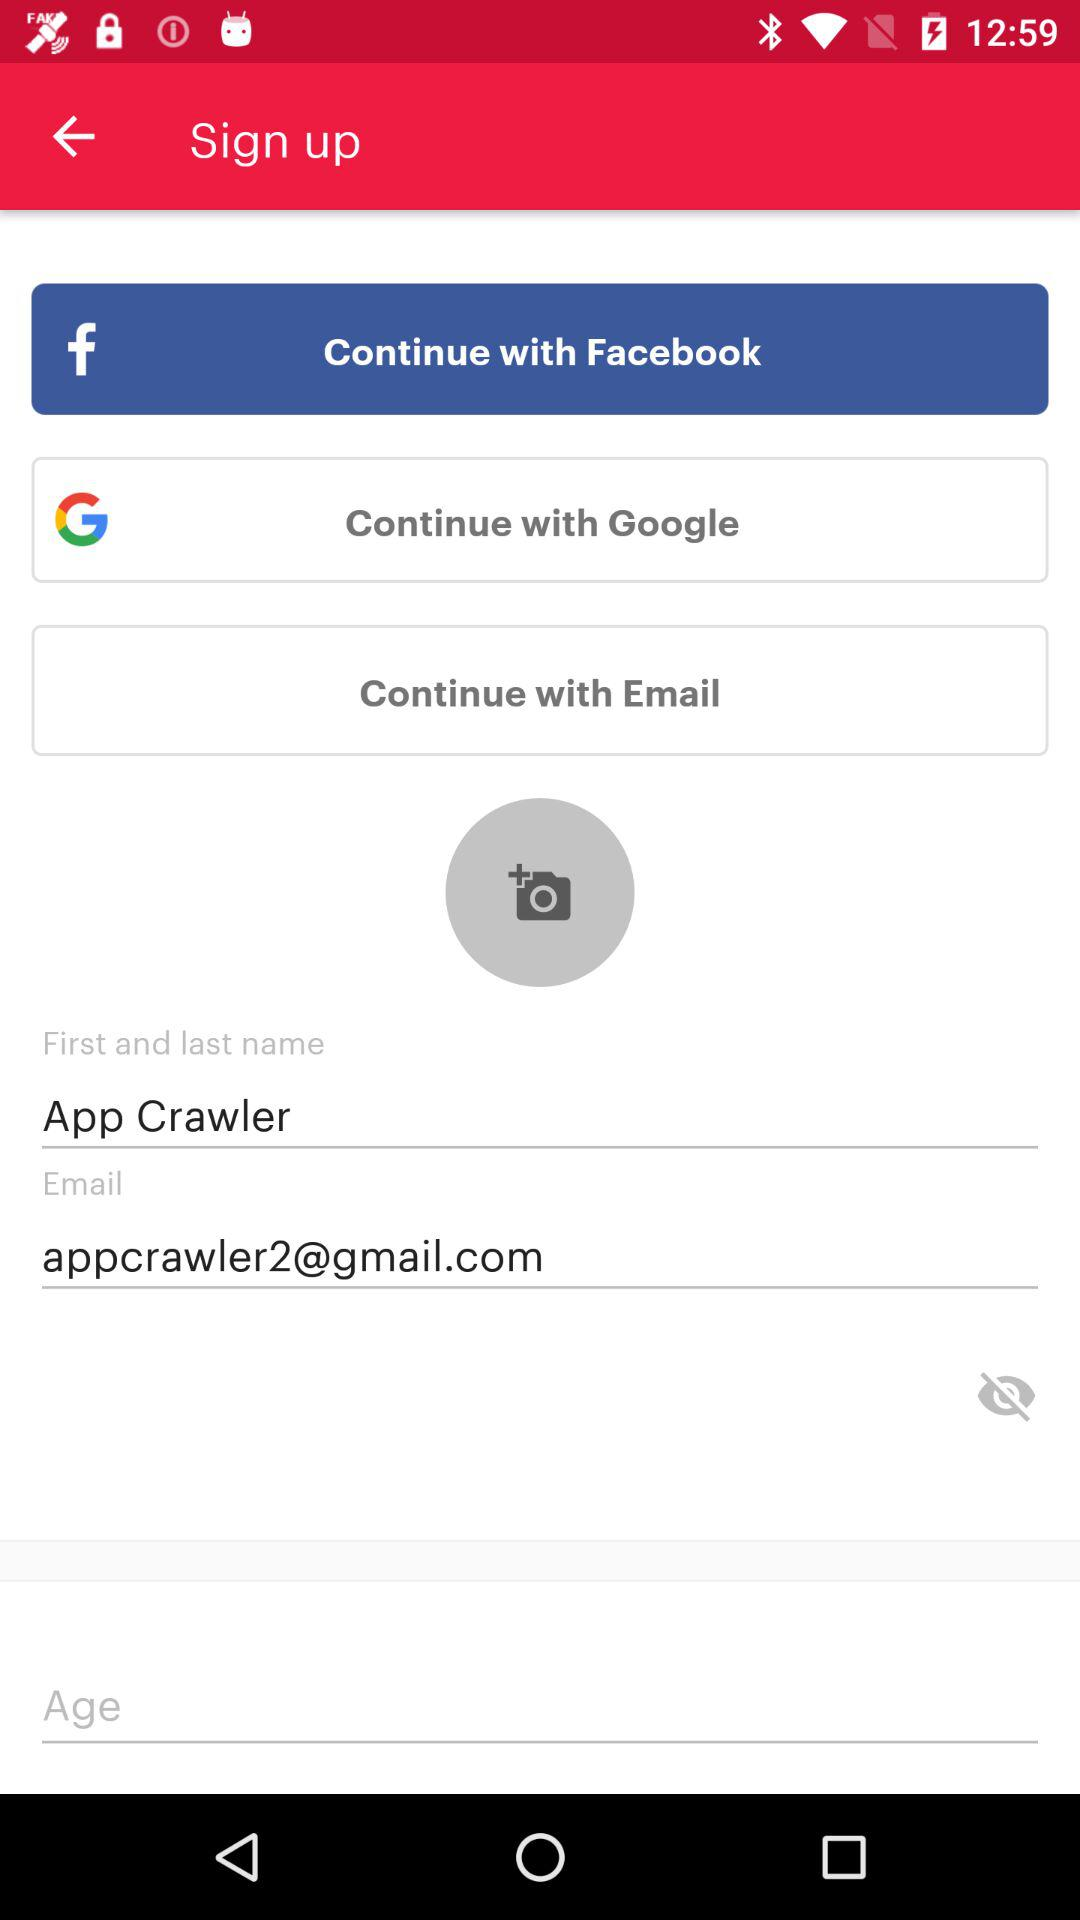What is the email address? The email address is appcrawler2@gmail.com. 